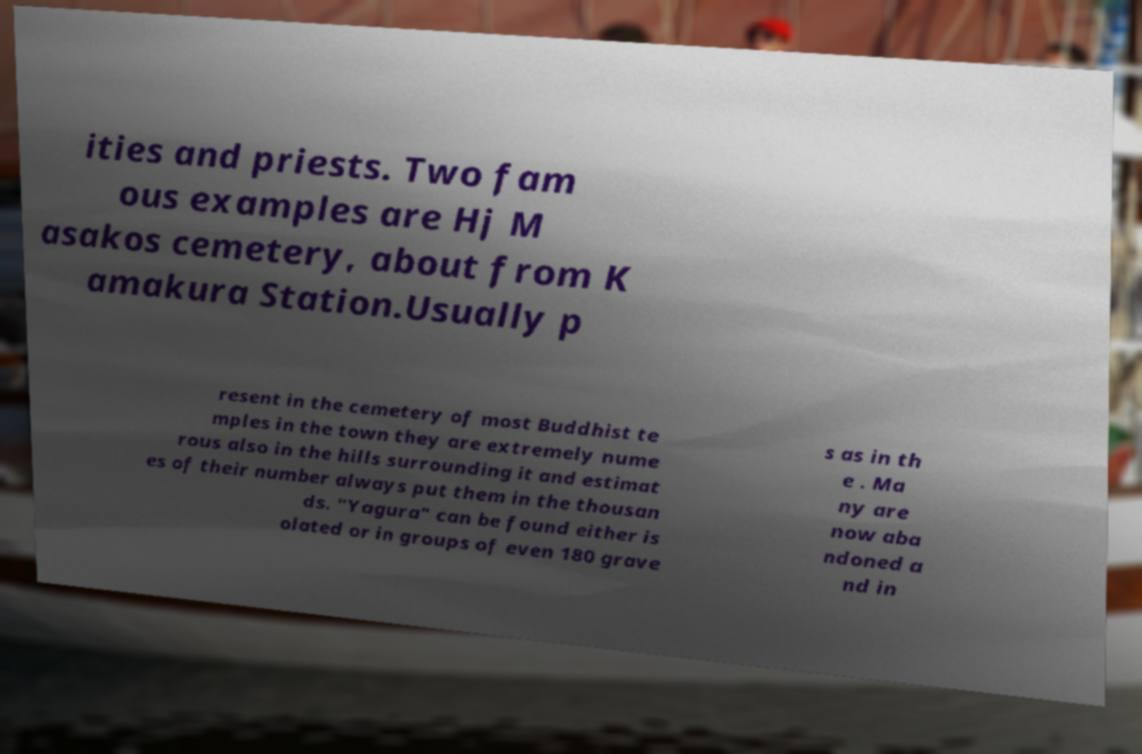Could you assist in decoding the text presented in this image and type it out clearly? ities and priests. Two fam ous examples are Hj M asakos cemetery, about from K amakura Station.Usually p resent in the cemetery of most Buddhist te mples in the town they are extremely nume rous also in the hills surrounding it and estimat es of their number always put them in the thousan ds. "Yagura" can be found either is olated or in groups of even 180 grave s as in th e . Ma ny are now aba ndoned a nd in 